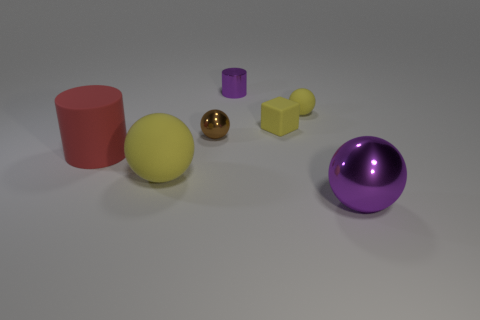There is a rubber thing that is on the right side of the rubber block; does it have the same size as the cube?
Your answer should be compact. Yes. Is the color of the tiny rubber block the same as the small matte sphere?
Your answer should be compact. Yes. Is the cylinder behind the brown ball made of the same material as the cylinder in front of the tiny purple shiny object?
Provide a succinct answer. No. What material is the large yellow thing that is the same shape as the large purple object?
Keep it short and to the point. Rubber. Do the yellow cube and the big cylinder have the same material?
Make the answer very short. Yes. The other sphere that is the same material as the brown sphere is what size?
Your answer should be compact. Large. How many small yellow objects are the same shape as the large metal object?
Your answer should be very brief. 1. Does the small brown object on the left side of the tiny block have the same shape as the purple object that is left of the purple metal ball?
Provide a succinct answer. No. What is the shape of the tiny object that is the same color as the big shiny thing?
Ensure brevity in your answer.  Cylinder. The small purple thing has what shape?
Offer a terse response. Cylinder. 